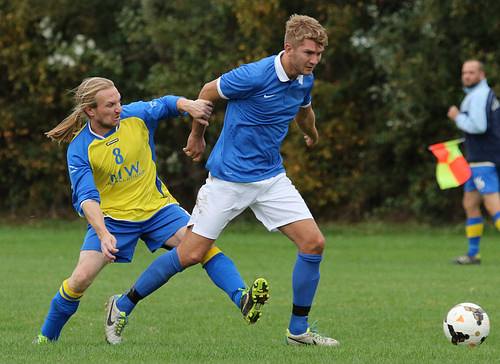<image>
Is the man in front of the man? Yes. The man is positioned in front of the man, appearing closer to the camera viewpoint. 